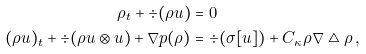Convert formula to latex. <formula><loc_0><loc_0><loc_500><loc_500>\rho _ { t } + \div ( \rho u ) & = 0 \\ ( \rho u ) _ { t } + \div ( \rho u \otimes u ) + \nabla p ( \rho ) & = \div ( \sigma [ u ] ) + C _ { \kappa } \rho \nabla \triangle \rho \, ,</formula> 